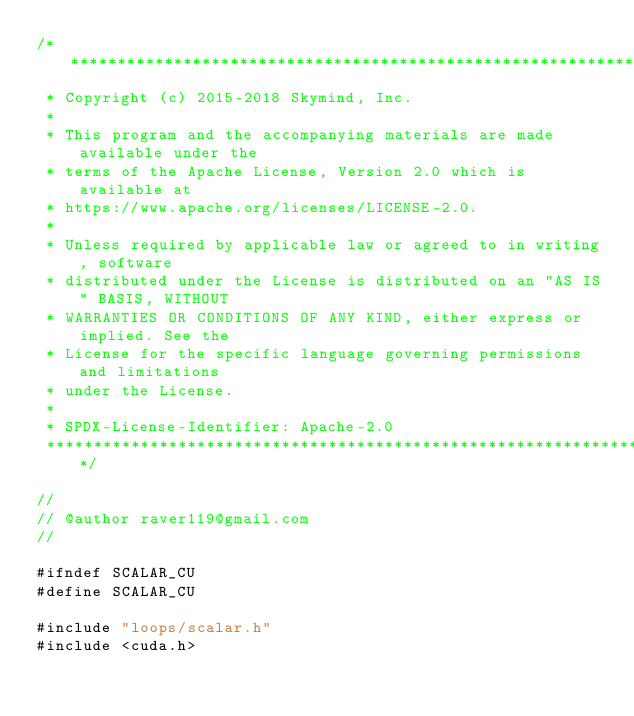<code> <loc_0><loc_0><loc_500><loc_500><_Cuda_>/*******************************************************************************
 * Copyright (c) 2015-2018 Skymind, Inc.
 *
 * This program and the accompanying materials are made available under the
 * terms of the Apache License, Version 2.0 which is available at
 * https://www.apache.org/licenses/LICENSE-2.0.
 *
 * Unless required by applicable law or agreed to in writing, software
 * distributed under the License is distributed on an "AS IS" BASIS, WITHOUT
 * WARRANTIES OR CONDITIONS OF ANY KIND, either express or implied. See the
 * License for the specific language governing permissions and limitations
 * under the License.
 *
 * SPDX-License-Identifier: Apache-2.0
 ******************************************************************************/

//
// @author raver119@gmail.com
//

#ifndef SCALAR_CU
#define SCALAR_CU

#include "loops/scalar.h"
#include <cuda.h></code> 